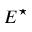Convert formula to latex. <formula><loc_0><loc_0><loc_500><loc_500>E ^ { ^ { * } }</formula> 